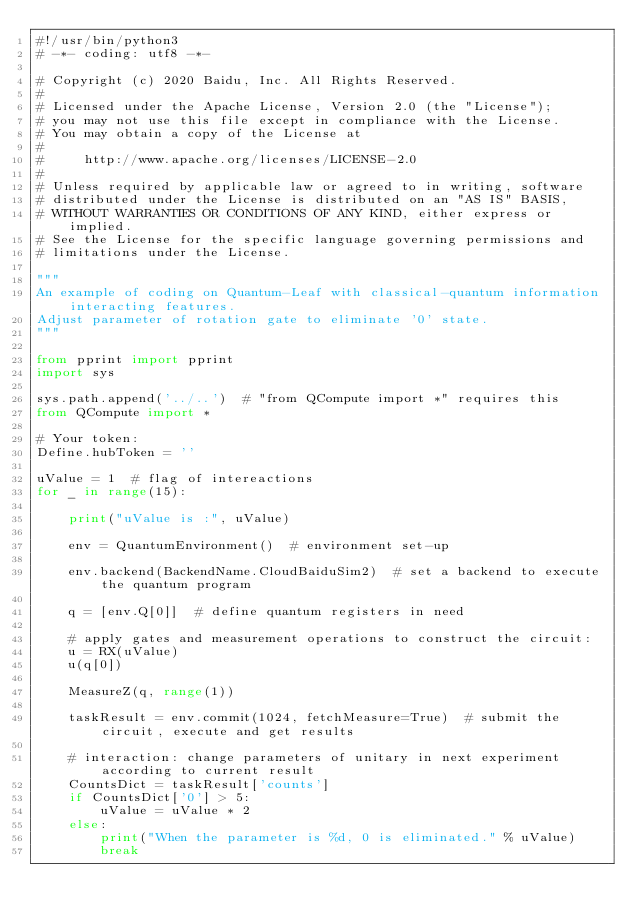Convert code to text. <code><loc_0><loc_0><loc_500><loc_500><_Python_>#!/usr/bin/python3
# -*- coding: utf8 -*-

# Copyright (c) 2020 Baidu, Inc. All Rights Reserved.
#
# Licensed under the Apache License, Version 2.0 (the "License");
# you may not use this file except in compliance with the License.
# You may obtain a copy of the License at
#
#     http://www.apache.org/licenses/LICENSE-2.0
#
# Unless required by applicable law or agreed to in writing, software
# distributed under the License is distributed on an "AS IS" BASIS,
# WITHOUT WARRANTIES OR CONDITIONS OF ANY KIND, either express or implied.
# See the License for the specific language governing permissions and
# limitations under the License.

"""
An example of coding on Quantum-Leaf with classical-quantum information interacting features.
Adjust parameter of rotation gate to eliminate '0' state.
"""

from pprint import pprint
import sys

sys.path.append('../..')  # "from QCompute import *" requires this
from QCompute import *

# Your token:
Define.hubToken = ''

uValue = 1  # flag of intereactions
for _ in range(15):

    print("uValue is :", uValue)

    env = QuantumEnvironment()  # environment set-up

    env.backend(BackendName.CloudBaiduSim2)  # set a backend to execute the quantum program

    q = [env.Q[0]]  # define quantum registers in need

    # apply gates and measurement operations to construct the circuit:
    u = RX(uValue)
    u(q[0])

    MeasureZ(q, range(1))

    taskResult = env.commit(1024, fetchMeasure=True)  # submit the circuit, execute and get results

    # interaction: change parameters of unitary in next experiment according to current result
    CountsDict = taskResult['counts']
    if CountsDict['0'] > 5:
        uValue = uValue * 2
    else:
        print("When the parameter is %d, 0 is eliminated." % uValue)
        break</code> 